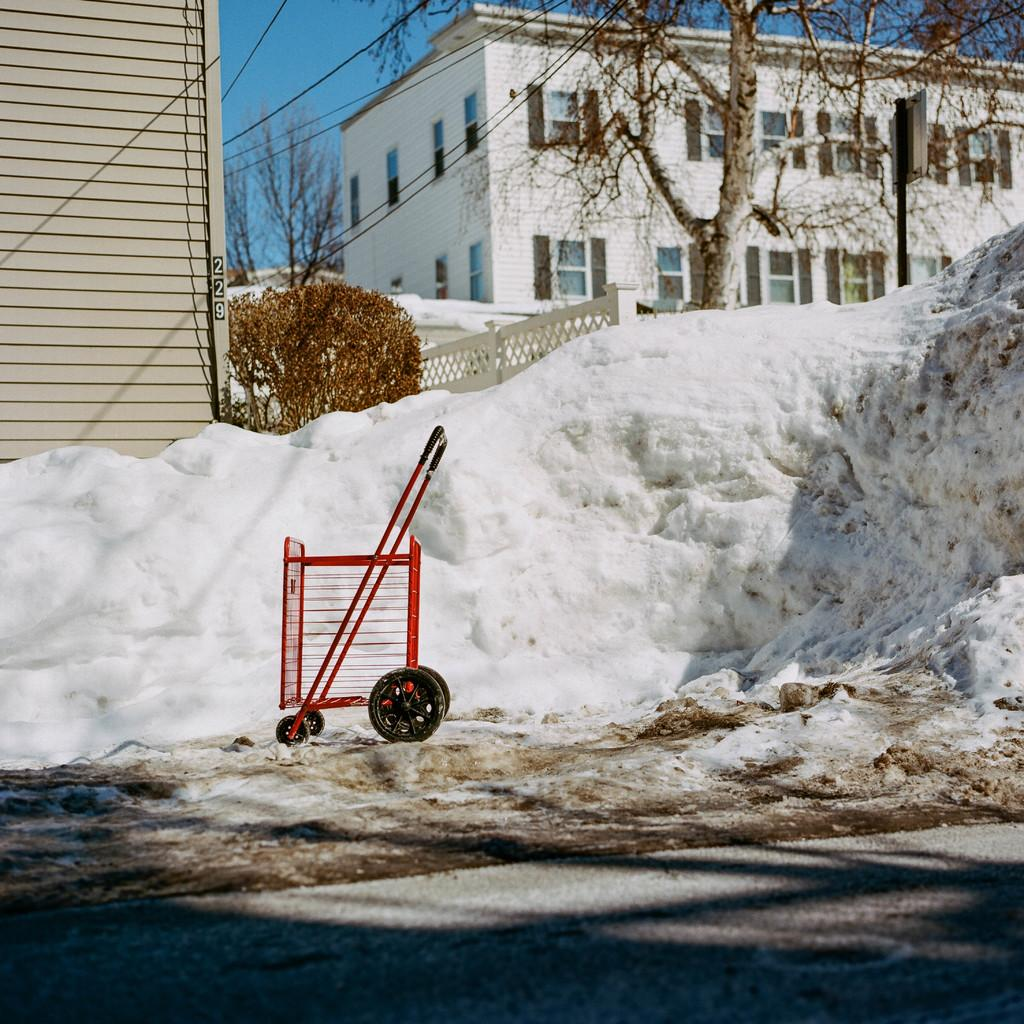What is the primary weather condition depicted in the image? There is snow in the image. What color is the trolley in the image? The trolley in the image is red. Can you describe any shadows visible in the image? Shadows are visible in the image. What type of natural elements can be seen in the image? There are trees in the image. What type of man-made structures are present in the image? There are buildings in the image. What type of infrastructure is present in the image? Wires and a pole are present in the image. What type of signage is present in the image? There is a board in the image. What type of openings can be seen in the buildings? Windows are visible in the image. What is visible in the background of the image? The sky is visible in the background of the image. Can you hear the sound of a volleyball being played in the image? There is no sound present in the image, and there is no indication of a volleyball being played. What type of straw is sticking out of the snow in the image? There is no straw present in the image. 